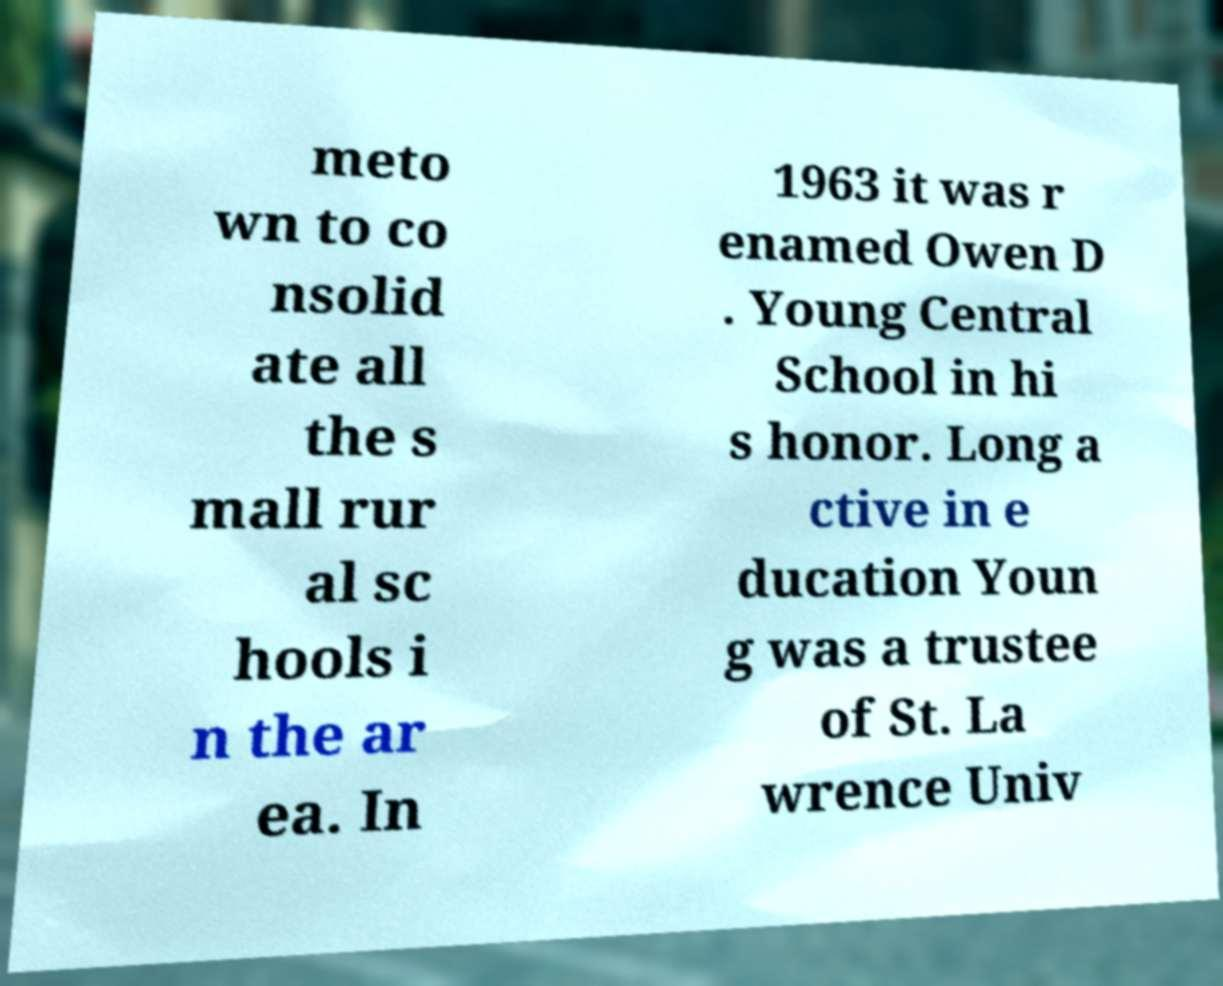Please read and relay the text visible in this image. What does it say? meto wn to co nsolid ate all the s mall rur al sc hools i n the ar ea. In 1963 it was r enamed Owen D . Young Central School in hi s honor. Long a ctive in e ducation Youn g was a trustee of St. La wrence Univ 